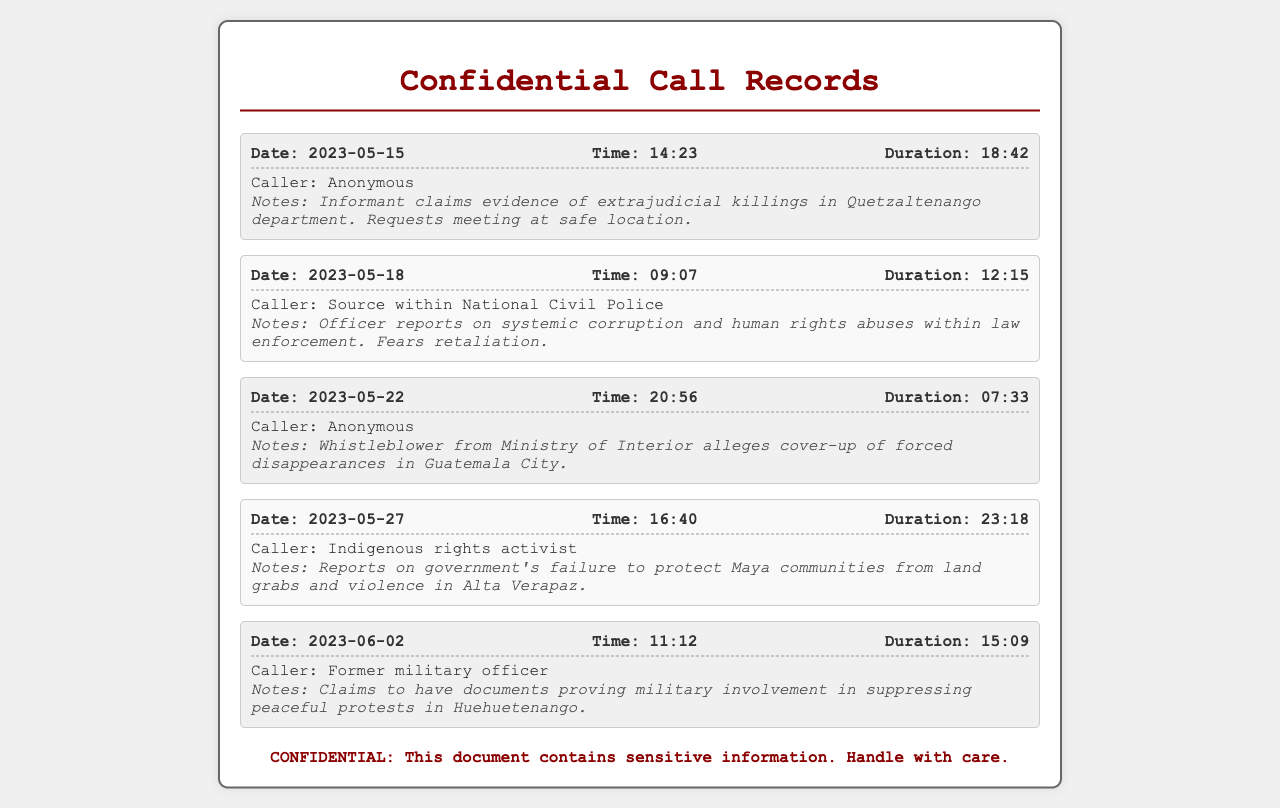What is the date of the first call? The first call is recorded on the date specified in the document, which is 2023-05-15.
Answer: 2023-05-15 Who is the caller of the second call? The second call has the caller identified as a "Source within National Civil Police".
Answer: Source within National Civil Police What is the duration of the call made on 2023-05-22? The duration of the call made on this date is found in the document, which is 07:33.
Answer: 07:33 What allegation was made by the anonymous caller on 2023-05-22? The specific allegation made is noted in the call records, which is about a cover-up of forced disappearances.
Answer: cover-up of forced disappearances How many calls were made by anonymous sources? The total number of calls made by anonymous sources can be counted in the document, which is two.
Answer: two What is the main concern reported by the Indigenous rights activist? The document notes the specific concern of the activist regarding government actions, which is the failure to protect Maya communities.
Answer: failure to protect Maya communities What type of document is this? The title and content clearly indicate that it consists of records related to phone communications, specifically call records.
Answer: Confidencial Call Records What is a key issue mentioned in the first call? The first call refers to a serious issue addressed by the caller, which is evidence of extrajudicial killings.
Answer: evidence of extrajudicial killings How long did the call with the former military officer last? The duration of this specific call is documented and can be found, which is 15:09.
Answer: 15:09 